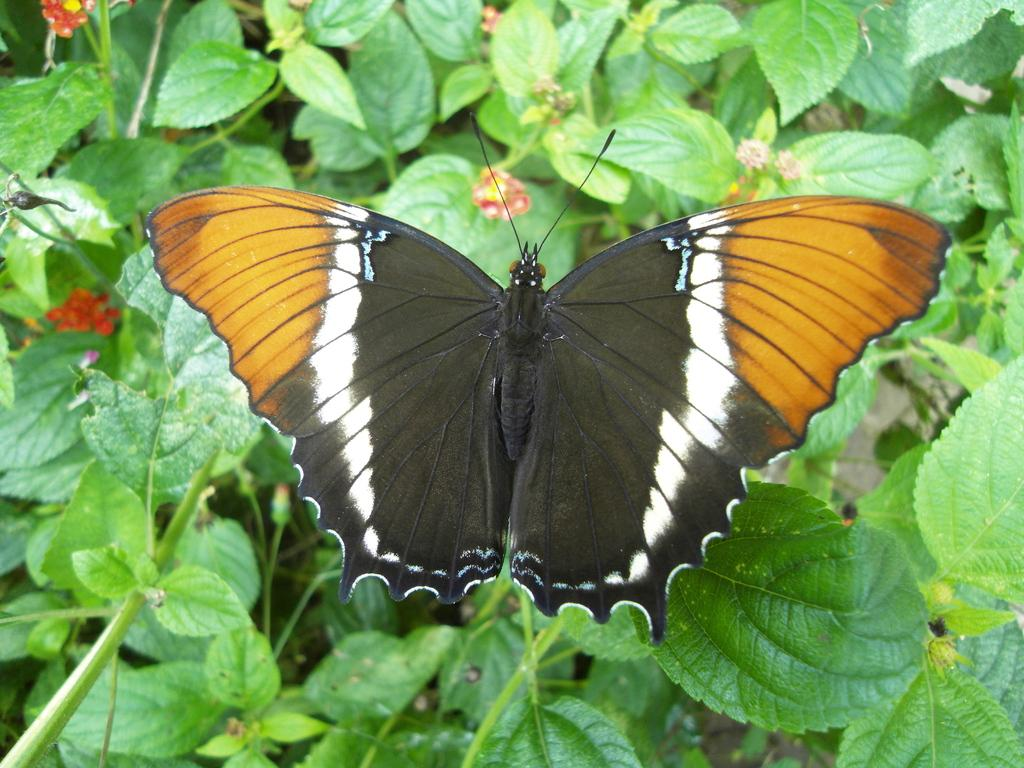What type of creature is present in the image? There is a butterfly in the image. What colors can be seen on the butterfly? The butterfly has black, white, and yellow colors. What is the butterfly resting on in the image? The butterfly is on green color plants. What other colorful elements can be seen in the image? There are red color flowers in the image. Can you tell me how many strangers are present in the image? There is no stranger present in the image; it features a butterfly on green plants with red flowers. 